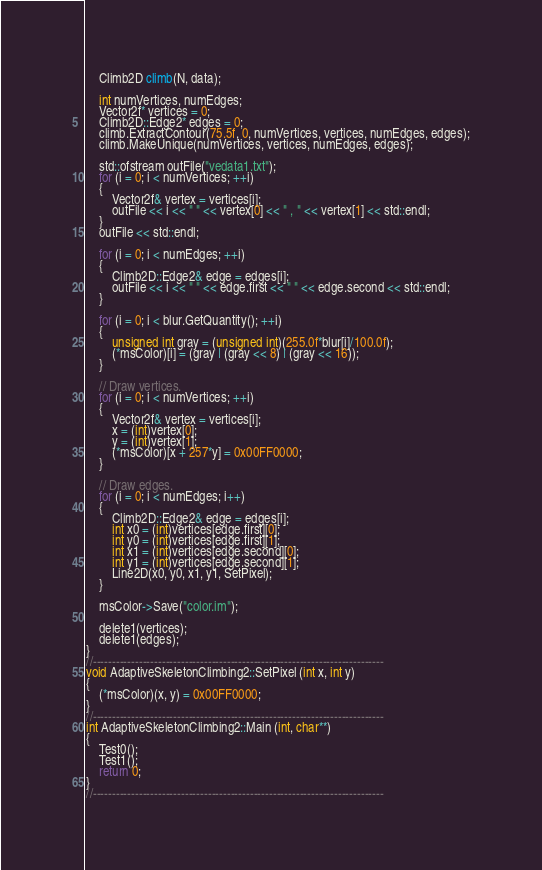Convert code to text. <code><loc_0><loc_0><loc_500><loc_500><_C++_>    Climb2D climb(N, data);

    int numVertices, numEdges;
    Vector2f* vertices = 0;
    Climb2D::Edge2* edges = 0;
    climb.ExtractContour(75.5f, 0, numVertices, vertices, numEdges, edges);
    climb.MakeUnique(numVertices, vertices, numEdges, edges);

    std::ofstream outFile("vedata1.txt");
    for (i = 0; i < numVertices; ++i)
    {
        Vector2f& vertex = vertices[i];
        outFile << i << " " << vertex[0] << " , " << vertex[1] << std::endl;
    }
    outFile << std::endl;

    for (i = 0; i < numEdges; ++i)
    {
        Climb2D::Edge2& edge = edges[i];
        outFile << i << " " << edge.first << " " << edge.second << std::endl;
    }

    for (i = 0; i < blur.GetQuantity(); ++i)
    {
        unsigned int gray = (unsigned int)(255.0f*blur[i]/100.0f);
        (*msColor)[i] = (gray | (gray << 8) | (gray << 16));
    }

    // Draw vertices.
    for (i = 0; i < numVertices; ++i)
    {
        Vector2f& vertex = vertices[i];
        x = (int)vertex[0];
        y = (int)vertex[1];
        (*msColor)[x + 257*y] = 0x00FF0000;
    }

    // Draw edges.
    for (i = 0; i < numEdges; i++)
    {
        Climb2D::Edge2& edge = edges[i];
        int x0 = (int)vertices[edge.first][0];
        int y0 = (int)vertices[edge.first][1];
        int x1 = (int)vertices[edge.second][0];
        int y1 = (int)vertices[edge.second][1];
        Line2D(x0, y0, x1, y1, SetPixel);
    }

    msColor->Save("color.im");

    delete1(vertices);
    delete1(edges);
}
//----------------------------------------------------------------------------
void AdaptiveSkeletonClimbing2::SetPixel (int x, int y)
{
    (*msColor)(x, y) = 0x00FF0000;
}
//----------------------------------------------------------------------------
int AdaptiveSkeletonClimbing2::Main (int, char**)
{
    Test0();
    Test1();
    return 0;
}
//----------------------------------------------------------------------------
</code> 